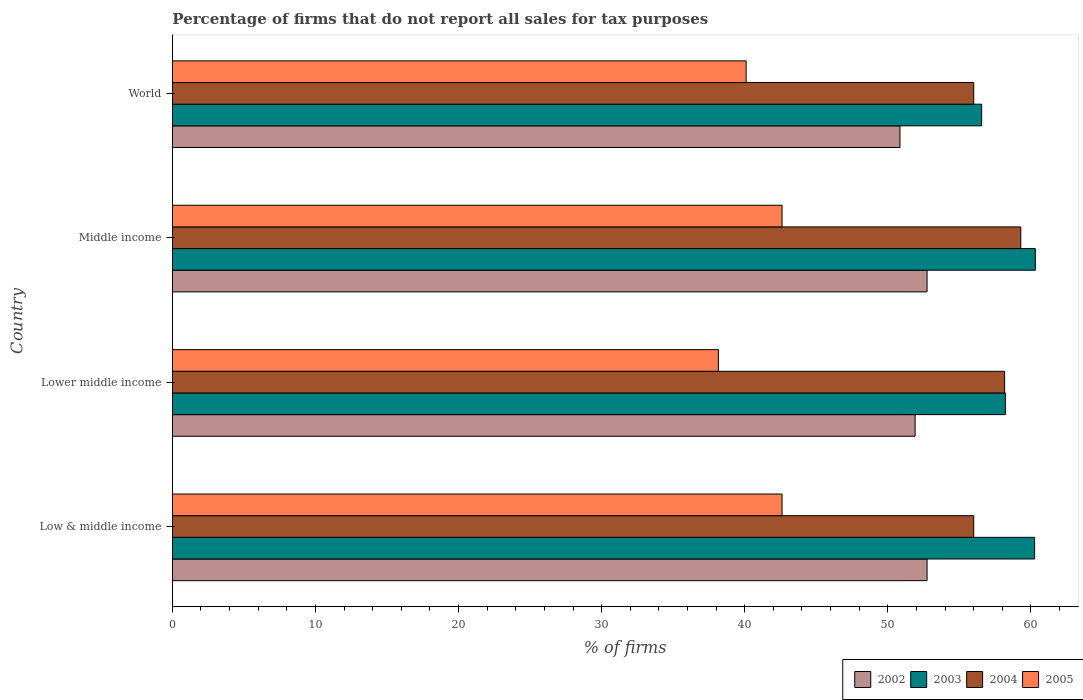How many bars are there on the 3rd tick from the bottom?
Your response must be concise. 4. What is the percentage of firms that do not report all sales for tax purposes in 2002 in Lower middle income?
Keep it short and to the point. 51.91. Across all countries, what is the maximum percentage of firms that do not report all sales for tax purposes in 2004?
Your response must be concise. 59.3. Across all countries, what is the minimum percentage of firms that do not report all sales for tax purposes in 2005?
Offer a very short reply. 38.16. In which country was the percentage of firms that do not report all sales for tax purposes in 2005 minimum?
Your answer should be compact. Lower middle income. What is the total percentage of firms that do not report all sales for tax purposes in 2003 in the graph?
Provide a short and direct response. 235.35. What is the difference between the percentage of firms that do not report all sales for tax purposes in 2003 in Lower middle income and that in World?
Make the answer very short. 1.66. What is the difference between the percentage of firms that do not report all sales for tax purposes in 2003 in Middle income and the percentage of firms that do not report all sales for tax purposes in 2002 in Low & middle income?
Ensure brevity in your answer.  7.57. What is the average percentage of firms that do not report all sales for tax purposes in 2002 per country?
Give a very brief answer. 52.06. What is the difference between the percentage of firms that do not report all sales for tax purposes in 2004 and percentage of firms that do not report all sales for tax purposes in 2003 in Middle income?
Provide a short and direct response. -1.02. What is the ratio of the percentage of firms that do not report all sales for tax purposes in 2002 in Low & middle income to that in Middle income?
Your answer should be compact. 1. Is the percentage of firms that do not report all sales for tax purposes in 2005 in Middle income less than that in World?
Offer a very short reply. No. What is the difference between the highest and the lowest percentage of firms that do not report all sales for tax purposes in 2004?
Provide a short and direct response. 3.29. In how many countries, is the percentage of firms that do not report all sales for tax purposes in 2003 greater than the average percentage of firms that do not report all sales for tax purposes in 2003 taken over all countries?
Give a very brief answer. 2. Is it the case that in every country, the sum of the percentage of firms that do not report all sales for tax purposes in 2004 and percentage of firms that do not report all sales for tax purposes in 2002 is greater than the sum of percentage of firms that do not report all sales for tax purposes in 2003 and percentage of firms that do not report all sales for tax purposes in 2005?
Your answer should be compact. No. What does the 2nd bar from the top in Lower middle income represents?
Your answer should be very brief. 2004. Is it the case that in every country, the sum of the percentage of firms that do not report all sales for tax purposes in 2004 and percentage of firms that do not report all sales for tax purposes in 2003 is greater than the percentage of firms that do not report all sales for tax purposes in 2005?
Offer a terse response. Yes. Does the graph contain any zero values?
Provide a succinct answer. No. Does the graph contain grids?
Your answer should be very brief. No. How many legend labels are there?
Your response must be concise. 4. How are the legend labels stacked?
Provide a succinct answer. Horizontal. What is the title of the graph?
Ensure brevity in your answer.  Percentage of firms that do not report all sales for tax purposes. Does "2011" appear as one of the legend labels in the graph?
Make the answer very short. No. What is the label or title of the X-axis?
Your response must be concise. % of firms. What is the % of firms of 2002 in Low & middle income?
Keep it short and to the point. 52.75. What is the % of firms of 2003 in Low & middle income?
Offer a very short reply. 60.26. What is the % of firms in 2004 in Low & middle income?
Your answer should be very brief. 56.01. What is the % of firms in 2005 in Low & middle income?
Give a very brief answer. 42.61. What is the % of firms of 2002 in Lower middle income?
Your answer should be compact. 51.91. What is the % of firms in 2003 in Lower middle income?
Give a very brief answer. 58.22. What is the % of firms in 2004 in Lower middle income?
Provide a short and direct response. 58.16. What is the % of firms of 2005 in Lower middle income?
Give a very brief answer. 38.16. What is the % of firms in 2002 in Middle income?
Provide a short and direct response. 52.75. What is the % of firms of 2003 in Middle income?
Make the answer very short. 60.31. What is the % of firms in 2004 in Middle income?
Your response must be concise. 59.3. What is the % of firms in 2005 in Middle income?
Your response must be concise. 42.61. What is the % of firms of 2002 in World?
Offer a very short reply. 50.85. What is the % of firms in 2003 in World?
Make the answer very short. 56.56. What is the % of firms of 2004 in World?
Give a very brief answer. 56.01. What is the % of firms in 2005 in World?
Offer a terse response. 40.1. Across all countries, what is the maximum % of firms of 2002?
Ensure brevity in your answer.  52.75. Across all countries, what is the maximum % of firms of 2003?
Offer a terse response. 60.31. Across all countries, what is the maximum % of firms of 2004?
Offer a very short reply. 59.3. Across all countries, what is the maximum % of firms in 2005?
Ensure brevity in your answer.  42.61. Across all countries, what is the minimum % of firms in 2002?
Provide a short and direct response. 50.85. Across all countries, what is the minimum % of firms of 2003?
Provide a succinct answer. 56.56. Across all countries, what is the minimum % of firms of 2004?
Your answer should be compact. 56.01. Across all countries, what is the minimum % of firms of 2005?
Make the answer very short. 38.16. What is the total % of firms in 2002 in the graph?
Keep it short and to the point. 208.25. What is the total % of firms of 2003 in the graph?
Provide a short and direct response. 235.35. What is the total % of firms of 2004 in the graph?
Offer a very short reply. 229.47. What is the total % of firms in 2005 in the graph?
Make the answer very short. 163.48. What is the difference between the % of firms in 2002 in Low & middle income and that in Lower middle income?
Offer a very short reply. 0.84. What is the difference between the % of firms in 2003 in Low & middle income and that in Lower middle income?
Offer a very short reply. 2.04. What is the difference between the % of firms of 2004 in Low & middle income and that in Lower middle income?
Make the answer very short. -2.16. What is the difference between the % of firms in 2005 in Low & middle income and that in Lower middle income?
Offer a terse response. 4.45. What is the difference between the % of firms in 2003 in Low & middle income and that in Middle income?
Ensure brevity in your answer.  -0.05. What is the difference between the % of firms of 2004 in Low & middle income and that in Middle income?
Offer a very short reply. -3.29. What is the difference between the % of firms in 2005 in Low & middle income and that in Middle income?
Keep it short and to the point. 0. What is the difference between the % of firms of 2002 in Low & middle income and that in World?
Provide a succinct answer. 1.89. What is the difference between the % of firms of 2005 in Low & middle income and that in World?
Ensure brevity in your answer.  2.51. What is the difference between the % of firms of 2002 in Lower middle income and that in Middle income?
Make the answer very short. -0.84. What is the difference between the % of firms of 2003 in Lower middle income and that in Middle income?
Offer a terse response. -2.09. What is the difference between the % of firms of 2004 in Lower middle income and that in Middle income?
Offer a very short reply. -1.13. What is the difference between the % of firms of 2005 in Lower middle income and that in Middle income?
Offer a terse response. -4.45. What is the difference between the % of firms of 2002 in Lower middle income and that in World?
Your response must be concise. 1.06. What is the difference between the % of firms in 2003 in Lower middle income and that in World?
Offer a very short reply. 1.66. What is the difference between the % of firms of 2004 in Lower middle income and that in World?
Keep it short and to the point. 2.16. What is the difference between the % of firms of 2005 in Lower middle income and that in World?
Your answer should be very brief. -1.94. What is the difference between the % of firms of 2002 in Middle income and that in World?
Give a very brief answer. 1.89. What is the difference between the % of firms of 2003 in Middle income and that in World?
Keep it short and to the point. 3.75. What is the difference between the % of firms of 2004 in Middle income and that in World?
Provide a short and direct response. 3.29. What is the difference between the % of firms in 2005 in Middle income and that in World?
Your answer should be very brief. 2.51. What is the difference between the % of firms of 2002 in Low & middle income and the % of firms of 2003 in Lower middle income?
Keep it short and to the point. -5.47. What is the difference between the % of firms of 2002 in Low & middle income and the % of firms of 2004 in Lower middle income?
Your answer should be very brief. -5.42. What is the difference between the % of firms in 2002 in Low & middle income and the % of firms in 2005 in Lower middle income?
Make the answer very short. 14.58. What is the difference between the % of firms in 2003 in Low & middle income and the % of firms in 2004 in Lower middle income?
Offer a terse response. 2.1. What is the difference between the % of firms of 2003 in Low & middle income and the % of firms of 2005 in Lower middle income?
Provide a short and direct response. 22.1. What is the difference between the % of firms of 2004 in Low & middle income and the % of firms of 2005 in Lower middle income?
Provide a succinct answer. 17.84. What is the difference between the % of firms of 2002 in Low & middle income and the % of firms of 2003 in Middle income?
Make the answer very short. -7.57. What is the difference between the % of firms in 2002 in Low & middle income and the % of firms in 2004 in Middle income?
Give a very brief answer. -6.55. What is the difference between the % of firms in 2002 in Low & middle income and the % of firms in 2005 in Middle income?
Ensure brevity in your answer.  10.13. What is the difference between the % of firms in 2003 in Low & middle income and the % of firms in 2004 in Middle income?
Provide a succinct answer. 0.96. What is the difference between the % of firms in 2003 in Low & middle income and the % of firms in 2005 in Middle income?
Offer a terse response. 17.65. What is the difference between the % of firms in 2004 in Low & middle income and the % of firms in 2005 in Middle income?
Give a very brief answer. 13.39. What is the difference between the % of firms in 2002 in Low & middle income and the % of firms in 2003 in World?
Provide a succinct answer. -3.81. What is the difference between the % of firms of 2002 in Low & middle income and the % of firms of 2004 in World?
Ensure brevity in your answer.  -3.26. What is the difference between the % of firms in 2002 in Low & middle income and the % of firms in 2005 in World?
Provide a short and direct response. 12.65. What is the difference between the % of firms in 2003 in Low & middle income and the % of firms in 2004 in World?
Keep it short and to the point. 4.25. What is the difference between the % of firms in 2003 in Low & middle income and the % of firms in 2005 in World?
Your answer should be very brief. 20.16. What is the difference between the % of firms of 2004 in Low & middle income and the % of firms of 2005 in World?
Your answer should be compact. 15.91. What is the difference between the % of firms of 2002 in Lower middle income and the % of firms of 2003 in Middle income?
Provide a short and direct response. -8.4. What is the difference between the % of firms of 2002 in Lower middle income and the % of firms of 2004 in Middle income?
Your response must be concise. -7.39. What is the difference between the % of firms of 2002 in Lower middle income and the % of firms of 2005 in Middle income?
Give a very brief answer. 9.3. What is the difference between the % of firms of 2003 in Lower middle income and the % of firms of 2004 in Middle income?
Provide a succinct answer. -1.08. What is the difference between the % of firms of 2003 in Lower middle income and the % of firms of 2005 in Middle income?
Your answer should be very brief. 15.61. What is the difference between the % of firms of 2004 in Lower middle income and the % of firms of 2005 in Middle income?
Provide a succinct answer. 15.55. What is the difference between the % of firms in 2002 in Lower middle income and the % of firms in 2003 in World?
Keep it short and to the point. -4.65. What is the difference between the % of firms in 2002 in Lower middle income and the % of firms in 2004 in World?
Your answer should be compact. -4.1. What is the difference between the % of firms in 2002 in Lower middle income and the % of firms in 2005 in World?
Offer a terse response. 11.81. What is the difference between the % of firms in 2003 in Lower middle income and the % of firms in 2004 in World?
Your response must be concise. 2.21. What is the difference between the % of firms of 2003 in Lower middle income and the % of firms of 2005 in World?
Give a very brief answer. 18.12. What is the difference between the % of firms of 2004 in Lower middle income and the % of firms of 2005 in World?
Ensure brevity in your answer.  18.07. What is the difference between the % of firms of 2002 in Middle income and the % of firms of 2003 in World?
Offer a terse response. -3.81. What is the difference between the % of firms of 2002 in Middle income and the % of firms of 2004 in World?
Provide a short and direct response. -3.26. What is the difference between the % of firms in 2002 in Middle income and the % of firms in 2005 in World?
Offer a terse response. 12.65. What is the difference between the % of firms of 2003 in Middle income and the % of firms of 2004 in World?
Offer a very short reply. 4.31. What is the difference between the % of firms in 2003 in Middle income and the % of firms in 2005 in World?
Provide a short and direct response. 20.21. What is the difference between the % of firms in 2004 in Middle income and the % of firms in 2005 in World?
Provide a short and direct response. 19.2. What is the average % of firms in 2002 per country?
Your answer should be compact. 52.06. What is the average % of firms of 2003 per country?
Give a very brief answer. 58.84. What is the average % of firms of 2004 per country?
Provide a short and direct response. 57.37. What is the average % of firms of 2005 per country?
Ensure brevity in your answer.  40.87. What is the difference between the % of firms of 2002 and % of firms of 2003 in Low & middle income?
Offer a terse response. -7.51. What is the difference between the % of firms in 2002 and % of firms in 2004 in Low & middle income?
Offer a terse response. -3.26. What is the difference between the % of firms in 2002 and % of firms in 2005 in Low & middle income?
Your response must be concise. 10.13. What is the difference between the % of firms in 2003 and % of firms in 2004 in Low & middle income?
Offer a terse response. 4.25. What is the difference between the % of firms in 2003 and % of firms in 2005 in Low & middle income?
Offer a very short reply. 17.65. What is the difference between the % of firms of 2004 and % of firms of 2005 in Low & middle income?
Offer a very short reply. 13.39. What is the difference between the % of firms in 2002 and % of firms in 2003 in Lower middle income?
Provide a short and direct response. -6.31. What is the difference between the % of firms in 2002 and % of firms in 2004 in Lower middle income?
Your response must be concise. -6.26. What is the difference between the % of firms of 2002 and % of firms of 2005 in Lower middle income?
Make the answer very short. 13.75. What is the difference between the % of firms of 2003 and % of firms of 2004 in Lower middle income?
Your answer should be compact. 0.05. What is the difference between the % of firms of 2003 and % of firms of 2005 in Lower middle income?
Your answer should be very brief. 20.06. What is the difference between the % of firms in 2004 and % of firms in 2005 in Lower middle income?
Give a very brief answer. 20. What is the difference between the % of firms in 2002 and % of firms in 2003 in Middle income?
Offer a very short reply. -7.57. What is the difference between the % of firms of 2002 and % of firms of 2004 in Middle income?
Give a very brief answer. -6.55. What is the difference between the % of firms of 2002 and % of firms of 2005 in Middle income?
Ensure brevity in your answer.  10.13. What is the difference between the % of firms in 2003 and % of firms in 2004 in Middle income?
Give a very brief answer. 1.02. What is the difference between the % of firms in 2003 and % of firms in 2005 in Middle income?
Provide a short and direct response. 17.7. What is the difference between the % of firms of 2004 and % of firms of 2005 in Middle income?
Provide a short and direct response. 16.69. What is the difference between the % of firms of 2002 and % of firms of 2003 in World?
Your answer should be very brief. -5.71. What is the difference between the % of firms in 2002 and % of firms in 2004 in World?
Your answer should be very brief. -5.15. What is the difference between the % of firms of 2002 and % of firms of 2005 in World?
Provide a succinct answer. 10.75. What is the difference between the % of firms of 2003 and % of firms of 2004 in World?
Your answer should be very brief. 0.56. What is the difference between the % of firms in 2003 and % of firms in 2005 in World?
Ensure brevity in your answer.  16.46. What is the difference between the % of firms in 2004 and % of firms in 2005 in World?
Keep it short and to the point. 15.91. What is the ratio of the % of firms in 2002 in Low & middle income to that in Lower middle income?
Provide a succinct answer. 1.02. What is the ratio of the % of firms in 2003 in Low & middle income to that in Lower middle income?
Provide a short and direct response. 1.04. What is the ratio of the % of firms in 2004 in Low & middle income to that in Lower middle income?
Ensure brevity in your answer.  0.96. What is the ratio of the % of firms in 2005 in Low & middle income to that in Lower middle income?
Offer a very short reply. 1.12. What is the ratio of the % of firms in 2002 in Low & middle income to that in Middle income?
Provide a succinct answer. 1. What is the ratio of the % of firms of 2003 in Low & middle income to that in Middle income?
Offer a very short reply. 1. What is the ratio of the % of firms in 2004 in Low & middle income to that in Middle income?
Your answer should be very brief. 0.94. What is the ratio of the % of firms of 2002 in Low & middle income to that in World?
Provide a short and direct response. 1.04. What is the ratio of the % of firms of 2003 in Low & middle income to that in World?
Offer a terse response. 1.07. What is the ratio of the % of firms of 2004 in Low & middle income to that in World?
Provide a succinct answer. 1. What is the ratio of the % of firms in 2005 in Low & middle income to that in World?
Offer a terse response. 1.06. What is the ratio of the % of firms of 2002 in Lower middle income to that in Middle income?
Your answer should be compact. 0.98. What is the ratio of the % of firms of 2003 in Lower middle income to that in Middle income?
Your answer should be very brief. 0.97. What is the ratio of the % of firms in 2004 in Lower middle income to that in Middle income?
Offer a very short reply. 0.98. What is the ratio of the % of firms of 2005 in Lower middle income to that in Middle income?
Your response must be concise. 0.9. What is the ratio of the % of firms of 2002 in Lower middle income to that in World?
Ensure brevity in your answer.  1.02. What is the ratio of the % of firms in 2003 in Lower middle income to that in World?
Provide a short and direct response. 1.03. What is the ratio of the % of firms of 2004 in Lower middle income to that in World?
Your response must be concise. 1.04. What is the ratio of the % of firms in 2005 in Lower middle income to that in World?
Make the answer very short. 0.95. What is the ratio of the % of firms in 2002 in Middle income to that in World?
Give a very brief answer. 1.04. What is the ratio of the % of firms of 2003 in Middle income to that in World?
Your response must be concise. 1.07. What is the ratio of the % of firms in 2004 in Middle income to that in World?
Keep it short and to the point. 1.06. What is the ratio of the % of firms in 2005 in Middle income to that in World?
Provide a succinct answer. 1.06. What is the difference between the highest and the second highest % of firms of 2002?
Offer a terse response. 0. What is the difference between the highest and the second highest % of firms in 2003?
Make the answer very short. 0.05. What is the difference between the highest and the second highest % of firms in 2004?
Give a very brief answer. 1.13. What is the difference between the highest and the lowest % of firms in 2002?
Your response must be concise. 1.89. What is the difference between the highest and the lowest % of firms of 2003?
Your answer should be compact. 3.75. What is the difference between the highest and the lowest % of firms in 2004?
Your answer should be compact. 3.29. What is the difference between the highest and the lowest % of firms in 2005?
Ensure brevity in your answer.  4.45. 